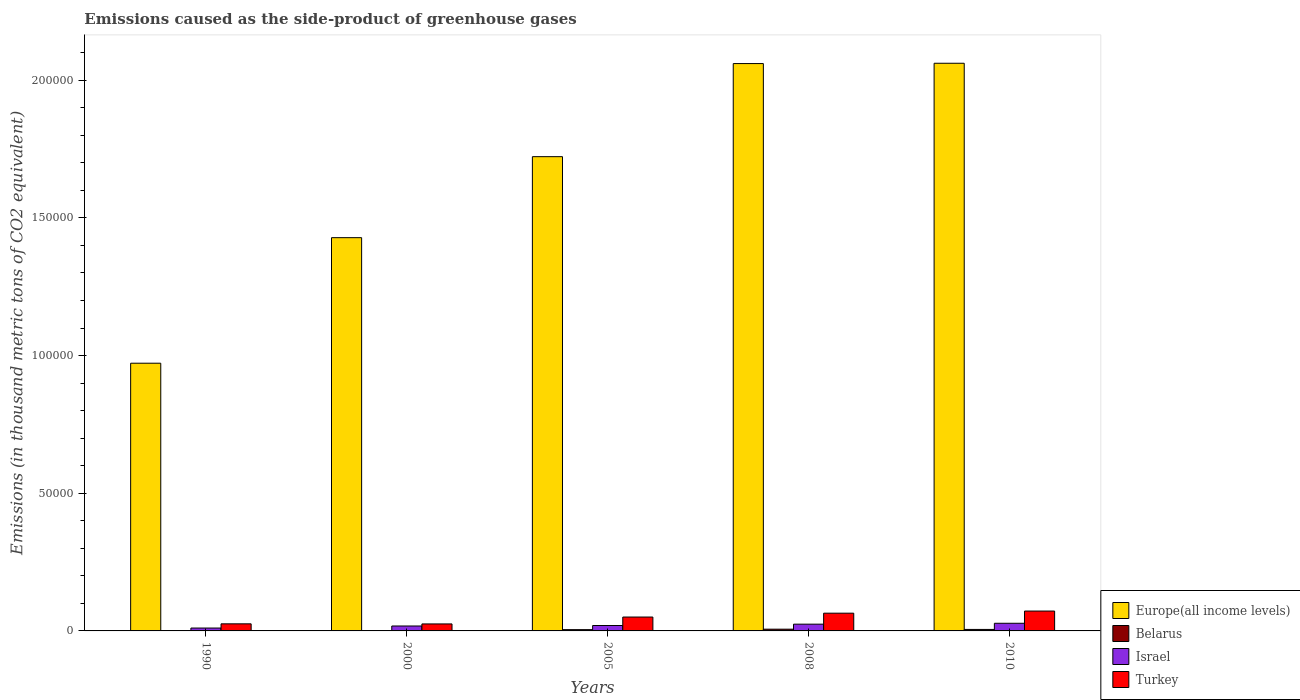How many different coloured bars are there?
Make the answer very short. 4. How many groups of bars are there?
Your response must be concise. 5. How many bars are there on the 4th tick from the left?
Your answer should be very brief. 4. How many bars are there on the 2nd tick from the right?
Your response must be concise. 4. In how many cases, is the number of bars for a given year not equal to the number of legend labels?
Give a very brief answer. 0. What is the emissions caused as the side-product of greenhouse gases in Israel in 2005?
Ensure brevity in your answer.  1967.4. Across all years, what is the maximum emissions caused as the side-product of greenhouse gases in Turkey?
Your answer should be compact. 7216. Across all years, what is the minimum emissions caused as the side-product of greenhouse gases in Europe(all income levels)?
Ensure brevity in your answer.  9.72e+04. In which year was the emissions caused as the side-product of greenhouse gases in Belarus maximum?
Make the answer very short. 2008. In which year was the emissions caused as the side-product of greenhouse gases in Europe(all income levels) minimum?
Ensure brevity in your answer.  1990. What is the total emissions caused as the side-product of greenhouse gases in Israel in the graph?
Make the answer very short. 1.00e+04. What is the difference between the emissions caused as the side-product of greenhouse gases in Turkey in 2000 and that in 2005?
Provide a succinct answer. -2502.8. What is the difference between the emissions caused as the side-product of greenhouse gases in Turkey in 2010 and the emissions caused as the side-product of greenhouse gases in Europe(all income levels) in 2005?
Give a very brief answer. -1.65e+05. What is the average emissions caused as the side-product of greenhouse gases in Israel per year?
Provide a short and direct response. 2006.7. In the year 2005, what is the difference between the emissions caused as the side-product of greenhouse gases in Turkey and emissions caused as the side-product of greenhouse gases in Israel?
Give a very brief answer. 3073.9. In how many years, is the emissions caused as the side-product of greenhouse gases in Belarus greater than 140000 thousand metric tons?
Your response must be concise. 0. What is the ratio of the emissions caused as the side-product of greenhouse gases in Europe(all income levels) in 2008 to that in 2010?
Provide a succinct answer. 1. Is the difference between the emissions caused as the side-product of greenhouse gases in Turkey in 1990 and 2008 greater than the difference between the emissions caused as the side-product of greenhouse gases in Israel in 1990 and 2008?
Your answer should be compact. No. What is the difference between the highest and the second highest emissions caused as the side-product of greenhouse gases in Belarus?
Ensure brevity in your answer.  96.2. What is the difference between the highest and the lowest emissions caused as the side-product of greenhouse gases in Belarus?
Offer a very short reply. 632.6. In how many years, is the emissions caused as the side-product of greenhouse gases in Belarus greater than the average emissions caused as the side-product of greenhouse gases in Belarus taken over all years?
Provide a short and direct response. 3. Is the sum of the emissions caused as the side-product of greenhouse gases in Europe(all income levels) in 2005 and 2008 greater than the maximum emissions caused as the side-product of greenhouse gases in Turkey across all years?
Your answer should be compact. Yes. Is it the case that in every year, the sum of the emissions caused as the side-product of greenhouse gases in Europe(all income levels) and emissions caused as the side-product of greenhouse gases in Turkey is greater than the sum of emissions caused as the side-product of greenhouse gases in Israel and emissions caused as the side-product of greenhouse gases in Belarus?
Provide a succinct answer. Yes. What does the 2nd bar from the left in 2005 represents?
Offer a terse response. Belarus. What does the 4th bar from the right in 2000 represents?
Provide a short and direct response. Europe(all income levels). Is it the case that in every year, the sum of the emissions caused as the side-product of greenhouse gases in Europe(all income levels) and emissions caused as the side-product of greenhouse gases in Israel is greater than the emissions caused as the side-product of greenhouse gases in Turkey?
Provide a succinct answer. Yes. Are the values on the major ticks of Y-axis written in scientific E-notation?
Your answer should be very brief. No. Does the graph contain any zero values?
Give a very brief answer. No. Does the graph contain grids?
Your response must be concise. No. What is the title of the graph?
Your response must be concise. Emissions caused as the side-product of greenhouse gases. What is the label or title of the X-axis?
Make the answer very short. Years. What is the label or title of the Y-axis?
Your answer should be compact. Emissions (in thousand metric tons of CO2 equivalent). What is the Emissions (in thousand metric tons of CO2 equivalent) of Europe(all income levels) in 1990?
Give a very brief answer. 9.72e+04. What is the Emissions (in thousand metric tons of CO2 equivalent) of Belarus in 1990?
Ensure brevity in your answer.  2.6. What is the Emissions (in thousand metric tons of CO2 equivalent) of Israel in 1990?
Ensure brevity in your answer.  1049.4. What is the Emissions (in thousand metric tons of CO2 equivalent) in Turkey in 1990?
Keep it short and to the point. 2572.7. What is the Emissions (in thousand metric tons of CO2 equivalent) of Europe(all income levels) in 2000?
Offer a very short reply. 1.43e+05. What is the Emissions (in thousand metric tons of CO2 equivalent) of Belarus in 2000?
Make the answer very short. 131.6. What is the Emissions (in thousand metric tons of CO2 equivalent) of Israel in 2000?
Ensure brevity in your answer.  1787.6. What is the Emissions (in thousand metric tons of CO2 equivalent) in Turkey in 2000?
Your answer should be compact. 2538.5. What is the Emissions (in thousand metric tons of CO2 equivalent) in Europe(all income levels) in 2005?
Ensure brevity in your answer.  1.72e+05. What is the Emissions (in thousand metric tons of CO2 equivalent) of Belarus in 2005?
Your response must be concise. 463.6. What is the Emissions (in thousand metric tons of CO2 equivalent) of Israel in 2005?
Make the answer very short. 1967.4. What is the Emissions (in thousand metric tons of CO2 equivalent) of Turkey in 2005?
Provide a short and direct response. 5041.3. What is the Emissions (in thousand metric tons of CO2 equivalent) in Europe(all income levels) in 2008?
Give a very brief answer. 2.06e+05. What is the Emissions (in thousand metric tons of CO2 equivalent) in Belarus in 2008?
Your response must be concise. 635.2. What is the Emissions (in thousand metric tons of CO2 equivalent) in Israel in 2008?
Offer a very short reply. 2452.1. What is the Emissions (in thousand metric tons of CO2 equivalent) in Turkey in 2008?
Give a very brief answer. 6441. What is the Emissions (in thousand metric tons of CO2 equivalent) of Europe(all income levels) in 2010?
Your answer should be very brief. 2.06e+05. What is the Emissions (in thousand metric tons of CO2 equivalent) of Belarus in 2010?
Your response must be concise. 539. What is the Emissions (in thousand metric tons of CO2 equivalent) in Israel in 2010?
Provide a succinct answer. 2777. What is the Emissions (in thousand metric tons of CO2 equivalent) in Turkey in 2010?
Your answer should be compact. 7216. Across all years, what is the maximum Emissions (in thousand metric tons of CO2 equivalent) of Europe(all income levels)?
Your response must be concise. 2.06e+05. Across all years, what is the maximum Emissions (in thousand metric tons of CO2 equivalent) of Belarus?
Give a very brief answer. 635.2. Across all years, what is the maximum Emissions (in thousand metric tons of CO2 equivalent) in Israel?
Your response must be concise. 2777. Across all years, what is the maximum Emissions (in thousand metric tons of CO2 equivalent) in Turkey?
Your answer should be compact. 7216. Across all years, what is the minimum Emissions (in thousand metric tons of CO2 equivalent) of Europe(all income levels)?
Offer a terse response. 9.72e+04. Across all years, what is the minimum Emissions (in thousand metric tons of CO2 equivalent) of Belarus?
Offer a very short reply. 2.6. Across all years, what is the minimum Emissions (in thousand metric tons of CO2 equivalent) in Israel?
Your answer should be very brief. 1049.4. Across all years, what is the minimum Emissions (in thousand metric tons of CO2 equivalent) in Turkey?
Offer a very short reply. 2538.5. What is the total Emissions (in thousand metric tons of CO2 equivalent) in Europe(all income levels) in the graph?
Offer a terse response. 8.25e+05. What is the total Emissions (in thousand metric tons of CO2 equivalent) of Belarus in the graph?
Keep it short and to the point. 1772. What is the total Emissions (in thousand metric tons of CO2 equivalent) in Israel in the graph?
Give a very brief answer. 1.00e+04. What is the total Emissions (in thousand metric tons of CO2 equivalent) of Turkey in the graph?
Offer a terse response. 2.38e+04. What is the difference between the Emissions (in thousand metric tons of CO2 equivalent) in Europe(all income levels) in 1990 and that in 2000?
Ensure brevity in your answer.  -4.56e+04. What is the difference between the Emissions (in thousand metric tons of CO2 equivalent) of Belarus in 1990 and that in 2000?
Provide a short and direct response. -129. What is the difference between the Emissions (in thousand metric tons of CO2 equivalent) of Israel in 1990 and that in 2000?
Ensure brevity in your answer.  -738.2. What is the difference between the Emissions (in thousand metric tons of CO2 equivalent) of Turkey in 1990 and that in 2000?
Your response must be concise. 34.2. What is the difference between the Emissions (in thousand metric tons of CO2 equivalent) in Europe(all income levels) in 1990 and that in 2005?
Offer a terse response. -7.50e+04. What is the difference between the Emissions (in thousand metric tons of CO2 equivalent) of Belarus in 1990 and that in 2005?
Offer a very short reply. -461. What is the difference between the Emissions (in thousand metric tons of CO2 equivalent) in Israel in 1990 and that in 2005?
Provide a short and direct response. -918. What is the difference between the Emissions (in thousand metric tons of CO2 equivalent) in Turkey in 1990 and that in 2005?
Give a very brief answer. -2468.6. What is the difference between the Emissions (in thousand metric tons of CO2 equivalent) of Europe(all income levels) in 1990 and that in 2008?
Your answer should be very brief. -1.09e+05. What is the difference between the Emissions (in thousand metric tons of CO2 equivalent) in Belarus in 1990 and that in 2008?
Provide a short and direct response. -632.6. What is the difference between the Emissions (in thousand metric tons of CO2 equivalent) of Israel in 1990 and that in 2008?
Provide a succinct answer. -1402.7. What is the difference between the Emissions (in thousand metric tons of CO2 equivalent) of Turkey in 1990 and that in 2008?
Give a very brief answer. -3868.3. What is the difference between the Emissions (in thousand metric tons of CO2 equivalent) in Europe(all income levels) in 1990 and that in 2010?
Offer a very short reply. -1.09e+05. What is the difference between the Emissions (in thousand metric tons of CO2 equivalent) in Belarus in 1990 and that in 2010?
Your response must be concise. -536.4. What is the difference between the Emissions (in thousand metric tons of CO2 equivalent) of Israel in 1990 and that in 2010?
Your answer should be very brief. -1727.6. What is the difference between the Emissions (in thousand metric tons of CO2 equivalent) of Turkey in 1990 and that in 2010?
Provide a short and direct response. -4643.3. What is the difference between the Emissions (in thousand metric tons of CO2 equivalent) in Europe(all income levels) in 2000 and that in 2005?
Make the answer very short. -2.94e+04. What is the difference between the Emissions (in thousand metric tons of CO2 equivalent) of Belarus in 2000 and that in 2005?
Offer a very short reply. -332. What is the difference between the Emissions (in thousand metric tons of CO2 equivalent) in Israel in 2000 and that in 2005?
Make the answer very short. -179.8. What is the difference between the Emissions (in thousand metric tons of CO2 equivalent) of Turkey in 2000 and that in 2005?
Offer a very short reply. -2502.8. What is the difference between the Emissions (in thousand metric tons of CO2 equivalent) in Europe(all income levels) in 2000 and that in 2008?
Your response must be concise. -6.32e+04. What is the difference between the Emissions (in thousand metric tons of CO2 equivalent) in Belarus in 2000 and that in 2008?
Your response must be concise. -503.6. What is the difference between the Emissions (in thousand metric tons of CO2 equivalent) in Israel in 2000 and that in 2008?
Your answer should be compact. -664.5. What is the difference between the Emissions (in thousand metric tons of CO2 equivalent) in Turkey in 2000 and that in 2008?
Ensure brevity in your answer.  -3902.5. What is the difference between the Emissions (in thousand metric tons of CO2 equivalent) in Europe(all income levels) in 2000 and that in 2010?
Offer a very short reply. -6.33e+04. What is the difference between the Emissions (in thousand metric tons of CO2 equivalent) in Belarus in 2000 and that in 2010?
Your response must be concise. -407.4. What is the difference between the Emissions (in thousand metric tons of CO2 equivalent) of Israel in 2000 and that in 2010?
Make the answer very short. -989.4. What is the difference between the Emissions (in thousand metric tons of CO2 equivalent) of Turkey in 2000 and that in 2010?
Your answer should be very brief. -4677.5. What is the difference between the Emissions (in thousand metric tons of CO2 equivalent) of Europe(all income levels) in 2005 and that in 2008?
Provide a short and direct response. -3.38e+04. What is the difference between the Emissions (in thousand metric tons of CO2 equivalent) in Belarus in 2005 and that in 2008?
Offer a very short reply. -171.6. What is the difference between the Emissions (in thousand metric tons of CO2 equivalent) in Israel in 2005 and that in 2008?
Provide a short and direct response. -484.7. What is the difference between the Emissions (in thousand metric tons of CO2 equivalent) of Turkey in 2005 and that in 2008?
Provide a short and direct response. -1399.7. What is the difference between the Emissions (in thousand metric tons of CO2 equivalent) of Europe(all income levels) in 2005 and that in 2010?
Offer a very short reply. -3.39e+04. What is the difference between the Emissions (in thousand metric tons of CO2 equivalent) of Belarus in 2005 and that in 2010?
Give a very brief answer. -75.4. What is the difference between the Emissions (in thousand metric tons of CO2 equivalent) of Israel in 2005 and that in 2010?
Your answer should be very brief. -809.6. What is the difference between the Emissions (in thousand metric tons of CO2 equivalent) of Turkey in 2005 and that in 2010?
Your response must be concise. -2174.7. What is the difference between the Emissions (in thousand metric tons of CO2 equivalent) in Europe(all income levels) in 2008 and that in 2010?
Provide a succinct answer. -115.6. What is the difference between the Emissions (in thousand metric tons of CO2 equivalent) of Belarus in 2008 and that in 2010?
Offer a terse response. 96.2. What is the difference between the Emissions (in thousand metric tons of CO2 equivalent) in Israel in 2008 and that in 2010?
Provide a succinct answer. -324.9. What is the difference between the Emissions (in thousand metric tons of CO2 equivalent) of Turkey in 2008 and that in 2010?
Keep it short and to the point. -775. What is the difference between the Emissions (in thousand metric tons of CO2 equivalent) in Europe(all income levels) in 1990 and the Emissions (in thousand metric tons of CO2 equivalent) in Belarus in 2000?
Keep it short and to the point. 9.71e+04. What is the difference between the Emissions (in thousand metric tons of CO2 equivalent) of Europe(all income levels) in 1990 and the Emissions (in thousand metric tons of CO2 equivalent) of Israel in 2000?
Offer a terse response. 9.54e+04. What is the difference between the Emissions (in thousand metric tons of CO2 equivalent) in Europe(all income levels) in 1990 and the Emissions (in thousand metric tons of CO2 equivalent) in Turkey in 2000?
Ensure brevity in your answer.  9.47e+04. What is the difference between the Emissions (in thousand metric tons of CO2 equivalent) of Belarus in 1990 and the Emissions (in thousand metric tons of CO2 equivalent) of Israel in 2000?
Ensure brevity in your answer.  -1785. What is the difference between the Emissions (in thousand metric tons of CO2 equivalent) of Belarus in 1990 and the Emissions (in thousand metric tons of CO2 equivalent) of Turkey in 2000?
Keep it short and to the point. -2535.9. What is the difference between the Emissions (in thousand metric tons of CO2 equivalent) in Israel in 1990 and the Emissions (in thousand metric tons of CO2 equivalent) in Turkey in 2000?
Keep it short and to the point. -1489.1. What is the difference between the Emissions (in thousand metric tons of CO2 equivalent) in Europe(all income levels) in 1990 and the Emissions (in thousand metric tons of CO2 equivalent) in Belarus in 2005?
Provide a short and direct response. 9.68e+04. What is the difference between the Emissions (in thousand metric tons of CO2 equivalent) of Europe(all income levels) in 1990 and the Emissions (in thousand metric tons of CO2 equivalent) of Israel in 2005?
Give a very brief answer. 9.53e+04. What is the difference between the Emissions (in thousand metric tons of CO2 equivalent) of Europe(all income levels) in 1990 and the Emissions (in thousand metric tons of CO2 equivalent) of Turkey in 2005?
Give a very brief answer. 9.22e+04. What is the difference between the Emissions (in thousand metric tons of CO2 equivalent) of Belarus in 1990 and the Emissions (in thousand metric tons of CO2 equivalent) of Israel in 2005?
Give a very brief answer. -1964.8. What is the difference between the Emissions (in thousand metric tons of CO2 equivalent) in Belarus in 1990 and the Emissions (in thousand metric tons of CO2 equivalent) in Turkey in 2005?
Offer a very short reply. -5038.7. What is the difference between the Emissions (in thousand metric tons of CO2 equivalent) in Israel in 1990 and the Emissions (in thousand metric tons of CO2 equivalent) in Turkey in 2005?
Give a very brief answer. -3991.9. What is the difference between the Emissions (in thousand metric tons of CO2 equivalent) in Europe(all income levels) in 1990 and the Emissions (in thousand metric tons of CO2 equivalent) in Belarus in 2008?
Provide a succinct answer. 9.66e+04. What is the difference between the Emissions (in thousand metric tons of CO2 equivalent) of Europe(all income levels) in 1990 and the Emissions (in thousand metric tons of CO2 equivalent) of Israel in 2008?
Your answer should be very brief. 9.48e+04. What is the difference between the Emissions (in thousand metric tons of CO2 equivalent) of Europe(all income levels) in 1990 and the Emissions (in thousand metric tons of CO2 equivalent) of Turkey in 2008?
Give a very brief answer. 9.08e+04. What is the difference between the Emissions (in thousand metric tons of CO2 equivalent) in Belarus in 1990 and the Emissions (in thousand metric tons of CO2 equivalent) in Israel in 2008?
Make the answer very short. -2449.5. What is the difference between the Emissions (in thousand metric tons of CO2 equivalent) of Belarus in 1990 and the Emissions (in thousand metric tons of CO2 equivalent) of Turkey in 2008?
Offer a very short reply. -6438.4. What is the difference between the Emissions (in thousand metric tons of CO2 equivalent) of Israel in 1990 and the Emissions (in thousand metric tons of CO2 equivalent) of Turkey in 2008?
Your response must be concise. -5391.6. What is the difference between the Emissions (in thousand metric tons of CO2 equivalent) of Europe(all income levels) in 1990 and the Emissions (in thousand metric tons of CO2 equivalent) of Belarus in 2010?
Your response must be concise. 9.67e+04. What is the difference between the Emissions (in thousand metric tons of CO2 equivalent) in Europe(all income levels) in 1990 and the Emissions (in thousand metric tons of CO2 equivalent) in Israel in 2010?
Your answer should be compact. 9.45e+04. What is the difference between the Emissions (in thousand metric tons of CO2 equivalent) of Europe(all income levels) in 1990 and the Emissions (in thousand metric tons of CO2 equivalent) of Turkey in 2010?
Your answer should be very brief. 9.00e+04. What is the difference between the Emissions (in thousand metric tons of CO2 equivalent) of Belarus in 1990 and the Emissions (in thousand metric tons of CO2 equivalent) of Israel in 2010?
Provide a short and direct response. -2774.4. What is the difference between the Emissions (in thousand metric tons of CO2 equivalent) of Belarus in 1990 and the Emissions (in thousand metric tons of CO2 equivalent) of Turkey in 2010?
Provide a short and direct response. -7213.4. What is the difference between the Emissions (in thousand metric tons of CO2 equivalent) in Israel in 1990 and the Emissions (in thousand metric tons of CO2 equivalent) in Turkey in 2010?
Give a very brief answer. -6166.6. What is the difference between the Emissions (in thousand metric tons of CO2 equivalent) in Europe(all income levels) in 2000 and the Emissions (in thousand metric tons of CO2 equivalent) in Belarus in 2005?
Keep it short and to the point. 1.42e+05. What is the difference between the Emissions (in thousand metric tons of CO2 equivalent) of Europe(all income levels) in 2000 and the Emissions (in thousand metric tons of CO2 equivalent) of Israel in 2005?
Your response must be concise. 1.41e+05. What is the difference between the Emissions (in thousand metric tons of CO2 equivalent) of Europe(all income levels) in 2000 and the Emissions (in thousand metric tons of CO2 equivalent) of Turkey in 2005?
Provide a succinct answer. 1.38e+05. What is the difference between the Emissions (in thousand metric tons of CO2 equivalent) of Belarus in 2000 and the Emissions (in thousand metric tons of CO2 equivalent) of Israel in 2005?
Offer a terse response. -1835.8. What is the difference between the Emissions (in thousand metric tons of CO2 equivalent) in Belarus in 2000 and the Emissions (in thousand metric tons of CO2 equivalent) in Turkey in 2005?
Offer a terse response. -4909.7. What is the difference between the Emissions (in thousand metric tons of CO2 equivalent) in Israel in 2000 and the Emissions (in thousand metric tons of CO2 equivalent) in Turkey in 2005?
Offer a terse response. -3253.7. What is the difference between the Emissions (in thousand metric tons of CO2 equivalent) of Europe(all income levels) in 2000 and the Emissions (in thousand metric tons of CO2 equivalent) of Belarus in 2008?
Offer a very short reply. 1.42e+05. What is the difference between the Emissions (in thousand metric tons of CO2 equivalent) of Europe(all income levels) in 2000 and the Emissions (in thousand metric tons of CO2 equivalent) of Israel in 2008?
Your answer should be very brief. 1.40e+05. What is the difference between the Emissions (in thousand metric tons of CO2 equivalent) in Europe(all income levels) in 2000 and the Emissions (in thousand metric tons of CO2 equivalent) in Turkey in 2008?
Provide a short and direct response. 1.36e+05. What is the difference between the Emissions (in thousand metric tons of CO2 equivalent) of Belarus in 2000 and the Emissions (in thousand metric tons of CO2 equivalent) of Israel in 2008?
Your answer should be compact. -2320.5. What is the difference between the Emissions (in thousand metric tons of CO2 equivalent) of Belarus in 2000 and the Emissions (in thousand metric tons of CO2 equivalent) of Turkey in 2008?
Offer a terse response. -6309.4. What is the difference between the Emissions (in thousand metric tons of CO2 equivalent) of Israel in 2000 and the Emissions (in thousand metric tons of CO2 equivalent) of Turkey in 2008?
Your answer should be very brief. -4653.4. What is the difference between the Emissions (in thousand metric tons of CO2 equivalent) in Europe(all income levels) in 2000 and the Emissions (in thousand metric tons of CO2 equivalent) in Belarus in 2010?
Provide a succinct answer. 1.42e+05. What is the difference between the Emissions (in thousand metric tons of CO2 equivalent) of Europe(all income levels) in 2000 and the Emissions (in thousand metric tons of CO2 equivalent) of Israel in 2010?
Provide a short and direct response. 1.40e+05. What is the difference between the Emissions (in thousand metric tons of CO2 equivalent) in Europe(all income levels) in 2000 and the Emissions (in thousand metric tons of CO2 equivalent) in Turkey in 2010?
Offer a very short reply. 1.36e+05. What is the difference between the Emissions (in thousand metric tons of CO2 equivalent) of Belarus in 2000 and the Emissions (in thousand metric tons of CO2 equivalent) of Israel in 2010?
Ensure brevity in your answer.  -2645.4. What is the difference between the Emissions (in thousand metric tons of CO2 equivalent) in Belarus in 2000 and the Emissions (in thousand metric tons of CO2 equivalent) in Turkey in 2010?
Your answer should be very brief. -7084.4. What is the difference between the Emissions (in thousand metric tons of CO2 equivalent) in Israel in 2000 and the Emissions (in thousand metric tons of CO2 equivalent) in Turkey in 2010?
Make the answer very short. -5428.4. What is the difference between the Emissions (in thousand metric tons of CO2 equivalent) in Europe(all income levels) in 2005 and the Emissions (in thousand metric tons of CO2 equivalent) in Belarus in 2008?
Provide a short and direct response. 1.72e+05. What is the difference between the Emissions (in thousand metric tons of CO2 equivalent) of Europe(all income levels) in 2005 and the Emissions (in thousand metric tons of CO2 equivalent) of Israel in 2008?
Provide a short and direct response. 1.70e+05. What is the difference between the Emissions (in thousand metric tons of CO2 equivalent) in Europe(all income levels) in 2005 and the Emissions (in thousand metric tons of CO2 equivalent) in Turkey in 2008?
Provide a succinct answer. 1.66e+05. What is the difference between the Emissions (in thousand metric tons of CO2 equivalent) in Belarus in 2005 and the Emissions (in thousand metric tons of CO2 equivalent) in Israel in 2008?
Provide a short and direct response. -1988.5. What is the difference between the Emissions (in thousand metric tons of CO2 equivalent) in Belarus in 2005 and the Emissions (in thousand metric tons of CO2 equivalent) in Turkey in 2008?
Keep it short and to the point. -5977.4. What is the difference between the Emissions (in thousand metric tons of CO2 equivalent) in Israel in 2005 and the Emissions (in thousand metric tons of CO2 equivalent) in Turkey in 2008?
Your answer should be compact. -4473.6. What is the difference between the Emissions (in thousand metric tons of CO2 equivalent) in Europe(all income levels) in 2005 and the Emissions (in thousand metric tons of CO2 equivalent) in Belarus in 2010?
Ensure brevity in your answer.  1.72e+05. What is the difference between the Emissions (in thousand metric tons of CO2 equivalent) of Europe(all income levels) in 2005 and the Emissions (in thousand metric tons of CO2 equivalent) of Israel in 2010?
Offer a terse response. 1.69e+05. What is the difference between the Emissions (in thousand metric tons of CO2 equivalent) in Europe(all income levels) in 2005 and the Emissions (in thousand metric tons of CO2 equivalent) in Turkey in 2010?
Provide a succinct answer. 1.65e+05. What is the difference between the Emissions (in thousand metric tons of CO2 equivalent) of Belarus in 2005 and the Emissions (in thousand metric tons of CO2 equivalent) of Israel in 2010?
Offer a terse response. -2313.4. What is the difference between the Emissions (in thousand metric tons of CO2 equivalent) in Belarus in 2005 and the Emissions (in thousand metric tons of CO2 equivalent) in Turkey in 2010?
Ensure brevity in your answer.  -6752.4. What is the difference between the Emissions (in thousand metric tons of CO2 equivalent) of Israel in 2005 and the Emissions (in thousand metric tons of CO2 equivalent) of Turkey in 2010?
Keep it short and to the point. -5248.6. What is the difference between the Emissions (in thousand metric tons of CO2 equivalent) of Europe(all income levels) in 2008 and the Emissions (in thousand metric tons of CO2 equivalent) of Belarus in 2010?
Your answer should be compact. 2.06e+05. What is the difference between the Emissions (in thousand metric tons of CO2 equivalent) in Europe(all income levels) in 2008 and the Emissions (in thousand metric tons of CO2 equivalent) in Israel in 2010?
Provide a short and direct response. 2.03e+05. What is the difference between the Emissions (in thousand metric tons of CO2 equivalent) in Europe(all income levels) in 2008 and the Emissions (in thousand metric tons of CO2 equivalent) in Turkey in 2010?
Your answer should be compact. 1.99e+05. What is the difference between the Emissions (in thousand metric tons of CO2 equivalent) of Belarus in 2008 and the Emissions (in thousand metric tons of CO2 equivalent) of Israel in 2010?
Ensure brevity in your answer.  -2141.8. What is the difference between the Emissions (in thousand metric tons of CO2 equivalent) in Belarus in 2008 and the Emissions (in thousand metric tons of CO2 equivalent) in Turkey in 2010?
Make the answer very short. -6580.8. What is the difference between the Emissions (in thousand metric tons of CO2 equivalent) in Israel in 2008 and the Emissions (in thousand metric tons of CO2 equivalent) in Turkey in 2010?
Your answer should be very brief. -4763.9. What is the average Emissions (in thousand metric tons of CO2 equivalent) of Europe(all income levels) per year?
Give a very brief answer. 1.65e+05. What is the average Emissions (in thousand metric tons of CO2 equivalent) of Belarus per year?
Provide a short and direct response. 354.4. What is the average Emissions (in thousand metric tons of CO2 equivalent) in Israel per year?
Your answer should be very brief. 2006.7. What is the average Emissions (in thousand metric tons of CO2 equivalent) of Turkey per year?
Provide a short and direct response. 4761.9. In the year 1990, what is the difference between the Emissions (in thousand metric tons of CO2 equivalent) in Europe(all income levels) and Emissions (in thousand metric tons of CO2 equivalent) in Belarus?
Offer a very short reply. 9.72e+04. In the year 1990, what is the difference between the Emissions (in thousand metric tons of CO2 equivalent) in Europe(all income levels) and Emissions (in thousand metric tons of CO2 equivalent) in Israel?
Provide a short and direct response. 9.62e+04. In the year 1990, what is the difference between the Emissions (in thousand metric tons of CO2 equivalent) in Europe(all income levels) and Emissions (in thousand metric tons of CO2 equivalent) in Turkey?
Your response must be concise. 9.47e+04. In the year 1990, what is the difference between the Emissions (in thousand metric tons of CO2 equivalent) of Belarus and Emissions (in thousand metric tons of CO2 equivalent) of Israel?
Your response must be concise. -1046.8. In the year 1990, what is the difference between the Emissions (in thousand metric tons of CO2 equivalent) of Belarus and Emissions (in thousand metric tons of CO2 equivalent) of Turkey?
Offer a very short reply. -2570.1. In the year 1990, what is the difference between the Emissions (in thousand metric tons of CO2 equivalent) in Israel and Emissions (in thousand metric tons of CO2 equivalent) in Turkey?
Keep it short and to the point. -1523.3. In the year 2000, what is the difference between the Emissions (in thousand metric tons of CO2 equivalent) in Europe(all income levels) and Emissions (in thousand metric tons of CO2 equivalent) in Belarus?
Offer a very short reply. 1.43e+05. In the year 2000, what is the difference between the Emissions (in thousand metric tons of CO2 equivalent) of Europe(all income levels) and Emissions (in thousand metric tons of CO2 equivalent) of Israel?
Ensure brevity in your answer.  1.41e+05. In the year 2000, what is the difference between the Emissions (in thousand metric tons of CO2 equivalent) of Europe(all income levels) and Emissions (in thousand metric tons of CO2 equivalent) of Turkey?
Your response must be concise. 1.40e+05. In the year 2000, what is the difference between the Emissions (in thousand metric tons of CO2 equivalent) in Belarus and Emissions (in thousand metric tons of CO2 equivalent) in Israel?
Provide a short and direct response. -1656. In the year 2000, what is the difference between the Emissions (in thousand metric tons of CO2 equivalent) in Belarus and Emissions (in thousand metric tons of CO2 equivalent) in Turkey?
Your response must be concise. -2406.9. In the year 2000, what is the difference between the Emissions (in thousand metric tons of CO2 equivalent) of Israel and Emissions (in thousand metric tons of CO2 equivalent) of Turkey?
Ensure brevity in your answer.  -750.9. In the year 2005, what is the difference between the Emissions (in thousand metric tons of CO2 equivalent) in Europe(all income levels) and Emissions (in thousand metric tons of CO2 equivalent) in Belarus?
Your answer should be very brief. 1.72e+05. In the year 2005, what is the difference between the Emissions (in thousand metric tons of CO2 equivalent) of Europe(all income levels) and Emissions (in thousand metric tons of CO2 equivalent) of Israel?
Keep it short and to the point. 1.70e+05. In the year 2005, what is the difference between the Emissions (in thousand metric tons of CO2 equivalent) of Europe(all income levels) and Emissions (in thousand metric tons of CO2 equivalent) of Turkey?
Your answer should be very brief. 1.67e+05. In the year 2005, what is the difference between the Emissions (in thousand metric tons of CO2 equivalent) of Belarus and Emissions (in thousand metric tons of CO2 equivalent) of Israel?
Ensure brevity in your answer.  -1503.8. In the year 2005, what is the difference between the Emissions (in thousand metric tons of CO2 equivalent) in Belarus and Emissions (in thousand metric tons of CO2 equivalent) in Turkey?
Offer a terse response. -4577.7. In the year 2005, what is the difference between the Emissions (in thousand metric tons of CO2 equivalent) of Israel and Emissions (in thousand metric tons of CO2 equivalent) of Turkey?
Provide a short and direct response. -3073.9. In the year 2008, what is the difference between the Emissions (in thousand metric tons of CO2 equivalent) of Europe(all income levels) and Emissions (in thousand metric tons of CO2 equivalent) of Belarus?
Your answer should be very brief. 2.05e+05. In the year 2008, what is the difference between the Emissions (in thousand metric tons of CO2 equivalent) of Europe(all income levels) and Emissions (in thousand metric tons of CO2 equivalent) of Israel?
Provide a short and direct response. 2.04e+05. In the year 2008, what is the difference between the Emissions (in thousand metric tons of CO2 equivalent) in Europe(all income levels) and Emissions (in thousand metric tons of CO2 equivalent) in Turkey?
Offer a very short reply. 2.00e+05. In the year 2008, what is the difference between the Emissions (in thousand metric tons of CO2 equivalent) in Belarus and Emissions (in thousand metric tons of CO2 equivalent) in Israel?
Give a very brief answer. -1816.9. In the year 2008, what is the difference between the Emissions (in thousand metric tons of CO2 equivalent) in Belarus and Emissions (in thousand metric tons of CO2 equivalent) in Turkey?
Give a very brief answer. -5805.8. In the year 2008, what is the difference between the Emissions (in thousand metric tons of CO2 equivalent) of Israel and Emissions (in thousand metric tons of CO2 equivalent) of Turkey?
Your answer should be compact. -3988.9. In the year 2010, what is the difference between the Emissions (in thousand metric tons of CO2 equivalent) in Europe(all income levels) and Emissions (in thousand metric tons of CO2 equivalent) in Belarus?
Keep it short and to the point. 2.06e+05. In the year 2010, what is the difference between the Emissions (in thousand metric tons of CO2 equivalent) in Europe(all income levels) and Emissions (in thousand metric tons of CO2 equivalent) in Israel?
Give a very brief answer. 2.03e+05. In the year 2010, what is the difference between the Emissions (in thousand metric tons of CO2 equivalent) in Europe(all income levels) and Emissions (in thousand metric tons of CO2 equivalent) in Turkey?
Ensure brevity in your answer.  1.99e+05. In the year 2010, what is the difference between the Emissions (in thousand metric tons of CO2 equivalent) of Belarus and Emissions (in thousand metric tons of CO2 equivalent) of Israel?
Ensure brevity in your answer.  -2238. In the year 2010, what is the difference between the Emissions (in thousand metric tons of CO2 equivalent) in Belarus and Emissions (in thousand metric tons of CO2 equivalent) in Turkey?
Make the answer very short. -6677. In the year 2010, what is the difference between the Emissions (in thousand metric tons of CO2 equivalent) of Israel and Emissions (in thousand metric tons of CO2 equivalent) of Turkey?
Offer a terse response. -4439. What is the ratio of the Emissions (in thousand metric tons of CO2 equivalent) in Europe(all income levels) in 1990 to that in 2000?
Make the answer very short. 0.68. What is the ratio of the Emissions (in thousand metric tons of CO2 equivalent) in Belarus in 1990 to that in 2000?
Your response must be concise. 0.02. What is the ratio of the Emissions (in thousand metric tons of CO2 equivalent) in Israel in 1990 to that in 2000?
Make the answer very short. 0.59. What is the ratio of the Emissions (in thousand metric tons of CO2 equivalent) of Turkey in 1990 to that in 2000?
Offer a terse response. 1.01. What is the ratio of the Emissions (in thousand metric tons of CO2 equivalent) in Europe(all income levels) in 1990 to that in 2005?
Offer a terse response. 0.56. What is the ratio of the Emissions (in thousand metric tons of CO2 equivalent) of Belarus in 1990 to that in 2005?
Offer a very short reply. 0.01. What is the ratio of the Emissions (in thousand metric tons of CO2 equivalent) in Israel in 1990 to that in 2005?
Your answer should be very brief. 0.53. What is the ratio of the Emissions (in thousand metric tons of CO2 equivalent) in Turkey in 1990 to that in 2005?
Your response must be concise. 0.51. What is the ratio of the Emissions (in thousand metric tons of CO2 equivalent) of Europe(all income levels) in 1990 to that in 2008?
Give a very brief answer. 0.47. What is the ratio of the Emissions (in thousand metric tons of CO2 equivalent) in Belarus in 1990 to that in 2008?
Keep it short and to the point. 0. What is the ratio of the Emissions (in thousand metric tons of CO2 equivalent) of Israel in 1990 to that in 2008?
Provide a succinct answer. 0.43. What is the ratio of the Emissions (in thousand metric tons of CO2 equivalent) in Turkey in 1990 to that in 2008?
Your response must be concise. 0.4. What is the ratio of the Emissions (in thousand metric tons of CO2 equivalent) in Europe(all income levels) in 1990 to that in 2010?
Offer a terse response. 0.47. What is the ratio of the Emissions (in thousand metric tons of CO2 equivalent) of Belarus in 1990 to that in 2010?
Keep it short and to the point. 0. What is the ratio of the Emissions (in thousand metric tons of CO2 equivalent) in Israel in 1990 to that in 2010?
Keep it short and to the point. 0.38. What is the ratio of the Emissions (in thousand metric tons of CO2 equivalent) of Turkey in 1990 to that in 2010?
Make the answer very short. 0.36. What is the ratio of the Emissions (in thousand metric tons of CO2 equivalent) of Europe(all income levels) in 2000 to that in 2005?
Your response must be concise. 0.83. What is the ratio of the Emissions (in thousand metric tons of CO2 equivalent) of Belarus in 2000 to that in 2005?
Give a very brief answer. 0.28. What is the ratio of the Emissions (in thousand metric tons of CO2 equivalent) in Israel in 2000 to that in 2005?
Offer a terse response. 0.91. What is the ratio of the Emissions (in thousand metric tons of CO2 equivalent) in Turkey in 2000 to that in 2005?
Your response must be concise. 0.5. What is the ratio of the Emissions (in thousand metric tons of CO2 equivalent) in Europe(all income levels) in 2000 to that in 2008?
Your response must be concise. 0.69. What is the ratio of the Emissions (in thousand metric tons of CO2 equivalent) of Belarus in 2000 to that in 2008?
Your answer should be very brief. 0.21. What is the ratio of the Emissions (in thousand metric tons of CO2 equivalent) in Israel in 2000 to that in 2008?
Keep it short and to the point. 0.73. What is the ratio of the Emissions (in thousand metric tons of CO2 equivalent) of Turkey in 2000 to that in 2008?
Make the answer very short. 0.39. What is the ratio of the Emissions (in thousand metric tons of CO2 equivalent) of Europe(all income levels) in 2000 to that in 2010?
Ensure brevity in your answer.  0.69. What is the ratio of the Emissions (in thousand metric tons of CO2 equivalent) in Belarus in 2000 to that in 2010?
Provide a succinct answer. 0.24. What is the ratio of the Emissions (in thousand metric tons of CO2 equivalent) in Israel in 2000 to that in 2010?
Keep it short and to the point. 0.64. What is the ratio of the Emissions (in thousand metric tons of CO2 equivalent) in Turkey in 2000 to that in 2010?
Your response must be concise. 0.35. What is the ratio of the Emissions (in thousand metric tons of CO2 equivalent) in Europe(all income levels) in 2005 to that in 2008?
Provide a short and direct response. 0.84. What is the ratio of the Emissions (in thousand metric tons of CO2 equivalent) in Belarus in 2005 to that in 2008?
Offer a very short reply. 0.73. What is the ratio of the Emissions (in thousand metric tons of CO2 equivalent) in Israel in 2005 to that in 2008?
Keep it short and to the point. 0.8. What is the ratio of the Emissions (in thousand metric tons of CO2 equivalent) of Turkey in 2005 to that in 2008?
Your answer should be compact. 0.78. What is the ratio of the Emissions (in thousand metric tons of CO2 equivalent) in Europe(all income levels) in 2005 to that in 2010?
Offer a very short reply. 0.84. What is the ratio of the Emissions (in thousand metric tons of CO2 equivalent) in Belarus in 2005 to that in 2010?
Your answer should be very brief. 0.86. What is the ratio of the Emissions (in thousand metric tons of CO2 equivalent) of Israel in 2005 to that in 2010?
Your response must be concise. 0.71. What is the ratio of the Emissions (in thousand metric tons of CO2 equivalent) of Turkey in 2005 to that in 2010?
Offer a very short reply. 0.7. What is the ratio of the Emissions (in thousand metric tons of CO2 equivalent) of Belarus in 2008 to that in 2010?
Keep it short and to the point. 1.18. What is the ratio of the Emissions (in thousand metric tons of CO2 equivalent) in Israel in 2008 to that in 2010?
Your answer should be compact. 0.88. What is the ratio of the Emissions (in thousand metric tons of CO2 equivalent) in Turkey in 2008 to that in 2010?
Make the answer very short. 0.89. What is the difference between the highest and the second highest Emissions (in thousand metric tons of CO2 equivalent) in Europe(all income levels)?
Give a very brief answer. 115.6. What is the difference between the highest and the second highest Emissions (in thousand metric tons of CO2 equivalent) in Belarus?
Offer a terse response. 96.2. What is the difference between the highest and the second highest Emissions (in thousand metric tons of CO2 equivalent) of Israel?
Ensure brevity in your answer.  324.9. What is the difference between the highest and the second highest Emissions (in thousand metric tons of CO2 equivalent) in Turkey?
Make the answer very short. 775. What is the difference between the highest and the lowest Emissions (in thousand metric tons of CO2 equivalent) in Europe(all income levels)?
Ensure brevity in your answer.  1.09e+05. What is the difference between the highest and the lowest Emissions (in thousand metric tons of CO2 equivalent) in Belarus?
Your answer should be very brief. 632.6. What is the difference between the highest and the lowest Emissions (in thousand metric tons of CO2 equivalent) of Israel?
Give a very brief answer. 1727.6. What is the difference between the highest and the lowest Emissions (in thousand metric tons of CO2 equivalent) in Turkey?
Your answer should be very brief. 4677.5. 